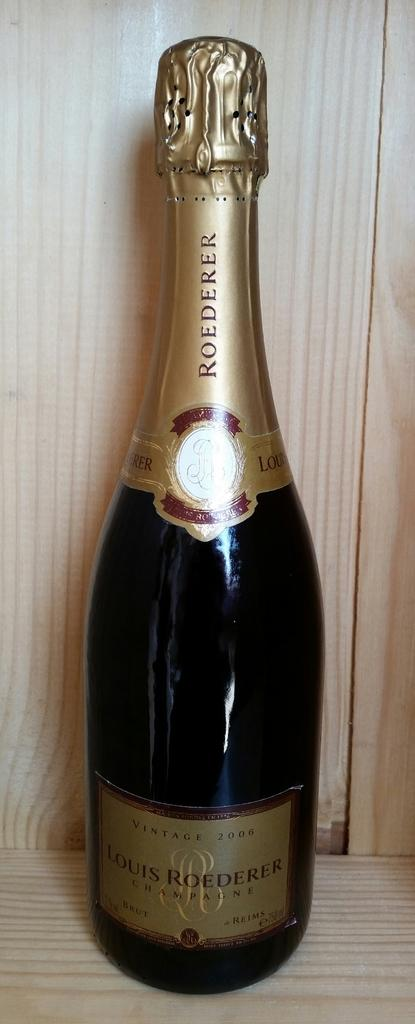<image>
Provide a brief description of the given image. A bottle of vintage 2006 Louis Roederer Champagne is pictured. 